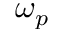Convert formula to latex. <formula><loc_0><loc_0><loc_500><loc_500>\omega _ { p }</formula> 